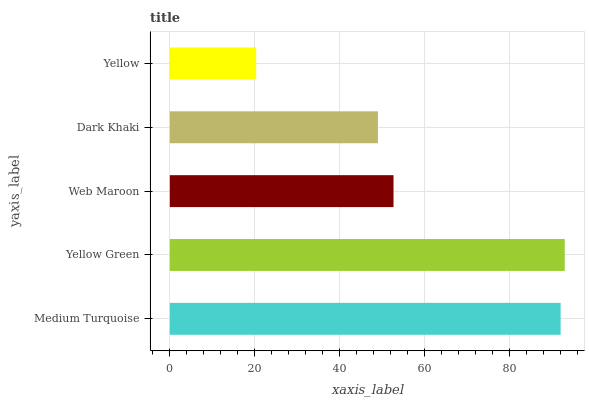Is Yellow the minimum?
Answer yes or no. Yes. Is Yellow Green the maximum?
Answer yes or no. Yes. Is Web Maroon the minimum?
Answer yes or no. No. Is Web Maroon the maximum?
Answer yes or no. No. Is Yellow Green greater than Web Maroon?
Answer yes or no. Yes. Is Web Maroon less than Yellow Green?
Answer yes or no. Yes. Is Web Maroon greater than Yellow Green?
Answer yes or no. No. Is Yellow Green less than Web Maroon?
Answer yes or no. No. Is Web Maroon the high median?
Answer yes or no. Yes. Is Web Maroon the low median?
Answer yes or no. Yes. Is Yellow Green the high median?
Answer yes or no. No. Is Yellow Green the low median?
Answer yes or no. No. 